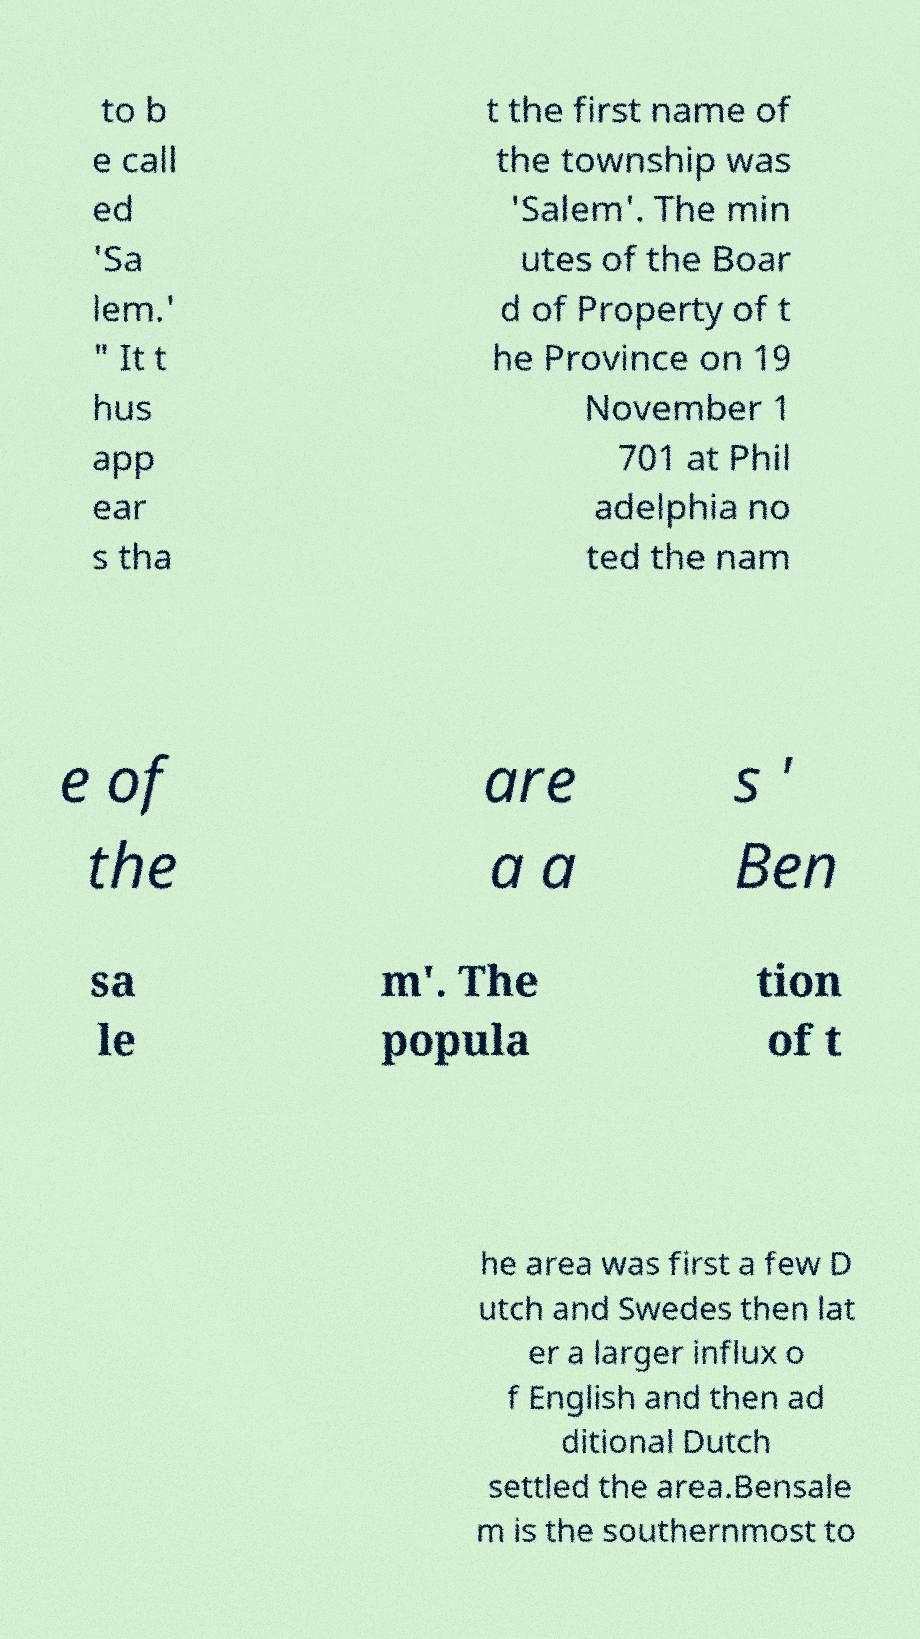Please identify and transcribe the text found in this image. to b e call ed 'Sa lem.' " It t hus app ear s tha t the first name of the township was 'Salem'. The min utes of the Boar d of Property of t he Province on 19 November 1 701 at Phil adelphia no ted the nam e of the are a a s ' Ben sa le m'. The popula tion of t he area was first a few D utch and Swedes then lat er a larger influx o f English and then ad ditional Dutch settled the area.Bensale m is the southernmost to 